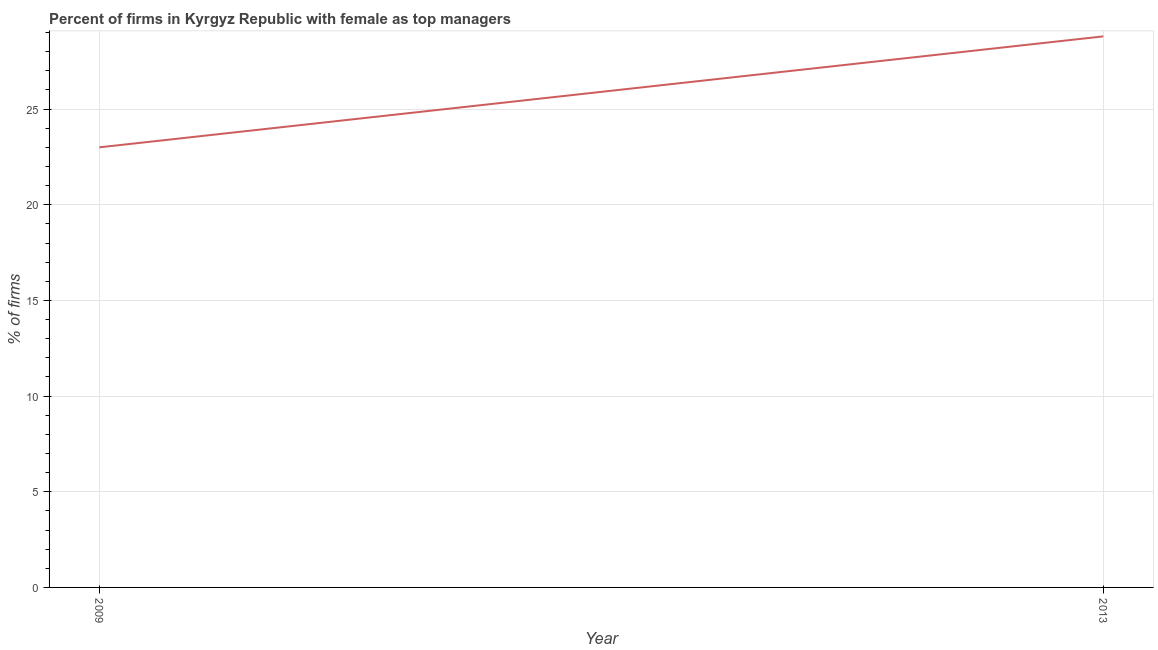What is the percentage of firms with female as top manager in 2009?
Your answer should be very brief. 23. Across all years, what is the maximum percentage of firms with female as top manager?
Offer a terse response. 28.8. Across all years, what is the minimum percentage of firms with female as top manager?
Your answer should be very brief. 23. In which year was the percentage of firms with female as top manager maximum?
Give a very brief answer. 2013. What is the sum of the percentage of firms with female as top manager?
Give a very brief answer. 51.8. What is the difference between the percentage of firms with female as top manager in 2009 and 2013?
Your answer should be compact. -5.8. What is the average percentage of firms with female as top manager per year?
Your answer should be compact. 25.9. What is the median percentage of firms with female as top manager?
Offer a very short reply. 25.9. What is the ratio of the percentage of firms with female as top manager in 2009 to that in 2013?
Your answer should be very brief. 0.8. Is the percentage of firms with female as top manager in 2009 less than that in 2013?
Your response must be concise. Yes. In how many years, is the percentage of firms with female as top manager greater than the average percentage of firms with female as top manager taken over all years?
Offer a terse response. 1. How many lines are there?
Make the answer very short. 1. How many years are there in the graph?
Keep it short and to the point. 2. What is the difference between two consecutive major ticks on the Y-axis?
Provide a succinct answer. 5. What is the title of the graph?
Provide a short and direct response. Percent of firms in Kyrgyz Republic with female as top managers. What is the label or title of the Y-axis?
Provide a short and direct response. % of firms. What is the % of firms of 2009?
Give a very brief answer. 23. What is the % of firms of 2013?
Your answer should be compact. 28.8. What is the ratio of the % of firms in 2009 to that in 2013?
Offer a very short reply. 0.8. 